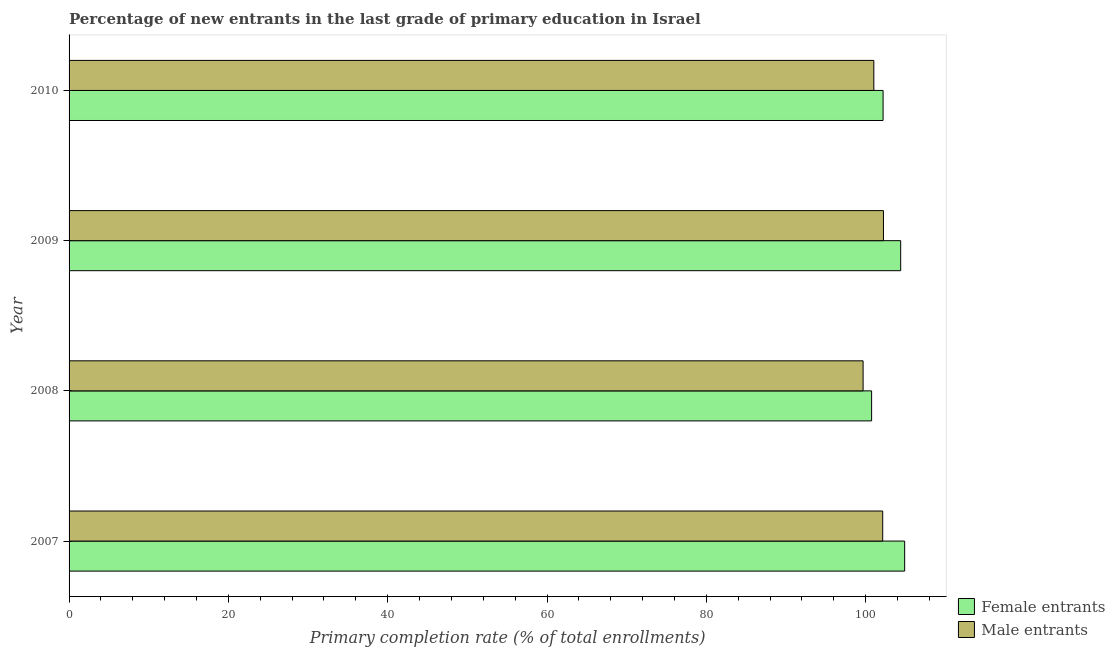Are the number of bars per tick equal to the number of legend labels?
Offer a terse response. Yes. How many bars are there on the 2nd tick from the top?
Ensure brevity in your answer.  2. How many bars are there on the 4th tick from the bottom?
Your answer should be compact. 2. What is the primary completion rate of male entrants in 2010?
Keep it short and to the point. 101.03. Across all years, what is the maximum primary completion rate of male entrants?
Make the answer very short. 102.24. Across all years, what is the minimum primary completion rate of female entrants?
Ensure brevity in your answer.  100.75. In which year was the primary completion rate of female entrants minimum?
Ensure brevity in your answer.  2008. What is the total primary completion rate of male entrants in the graph?
Make the answer very short. 405.1. What is the difference between the primary completion rate of female entrants in 2007 and that in 2010?
Offer a terse response. 2.71. What is the difference between the primary completion rate of female entrants in 2010 and the primary completion rate of male entrants in 2007?
Offer a very short reply. 0.05. What is the average primary completion rate of male entrants per year?
Provide a short and direct response. 101.28. In the year 2008, what is the difference between the primary completion rate of male entrants and primary completion rate of female entrants?
Give a very brief answer. -1.07. Is the primary completion rate of male entrants in 2007 less than that in 2010?
Make the answer very short. No. What is the difference between the highest and the second highest primary completion rate of female entrants?
Your answer should be very brief. 0.5. What is the difference between the highest and the lowest primary completion rate of female entrants?
Keep it short and to the point. 4.15. Is the sum of the primary completion rate of male entrants in 2008 and 2010 greater than the maximum primary completion rate of female entrants across all years?
Keep it short and to the point. Yes. What does the 1st bar from the top in 2007 represents?
Give a very brief answer. Male entrants. What does the 2nd bar from the bottom in 2008 represents?
Give a very brief answer. Male entrants. How many bars are there?
Make the answer very short. 8. How many years are there in the graph?
Ensure brevity in your answer.  4. What is the difference between two consecutive major ticks on the X-axis?
Provide a short and direct response. 20. Does the graph contain grids?
Your answer should be compact. No. How are the legend labels stacked?
Make the answer very short. Vertical. What is the title of the graph?
Your answer should be very brief. Percentage of new entrants in the last grade of primary education in Israel. Does "Public funds" appear as one of the legend labels in the graph?
Provide a short and direct response. No. What is the label or title of the X-axis?
Your answer should be very brief. Primary completion rate (% of total enrollments). What is the label or title of the Y-axis?
Give a very brief answer. Year. What is the Primary completion rate (% of total enrollments) in Female entrants in 2007?
Offer a very short reply. 104.9. What is the Primary completion rate (% of total enrollments) of Male entrants in 2007?
Keep it short and to the point. 102.15. What is the Primary completion rate (% of total enrollments) in Female entrants in 2008?
Provide a short and direct response. 100.75. What is the Primary completion rate (% of total enrollments) of Male entrants in 2008?
Your answer should be compact. 99.68. What is the Primary completion rate (% of total enrollments) in Female entrants in 2009?
Make the answer very short. 104.4. What is the Primary completion rate (% of total enrollments) of Male entrants in 2009?
Keep it short and to the point. 102.24. What is the Primary completion rate (% of total enrollments) in Female entrants in 2010?
Ensure brevity in your answer.  102.19. What is the Primary completion rate (% of total enrollments) in Male entrants in 2010?
Provide a succinct answer. 101.03. Across all years, what is the maximum Primary completion rate (% of total enrollments) in Female entrants?
Offer a terse response. 104.9. Across all years, what is the maximum Primary completion rate (% of total enrollments) in Male entrants?
Offer a terse response. 102.24. Across all years, what is the minimum Primary completion rate (% of total enrollments) in Female entrants?
Your response must be concise. 100.75. Across all years, what is the minimum Primary completion rate (% of total enrollments) in Male entrants?
Make the answer very short. 99.68. What is the total Primary completion rate (% of total enrollments) of Female entrants in the graph?
Offer a very short reply. 412.25. What is the total Primary completion rate (% of total enrollments) of Male entrants in the graph?
Offer a terse response. 405.1. What is the difference between the Primary completion rate (% of total enrollments) in Female entrants in 2007 and that in 2008?
Your response must be concise. 4.15. What is the difference between the Primary completion rate (% of total enrollments) of Male entrants in 2007 and that in 2008?
Provide a short and direct response. 2.46. What is the difference between the Primary completion rate (% of total enrollments) in Female entrants in 2007 and that in 2009?
Offer a very short reply. 0.5. What is the difference between the Primary completion rate (% of total enrollments) in Male entrants in 2007 and that in 2009?
Ensure brevity in your answer.  -0.09. What is the difference between the Primary completion rate (% of total enrollments) of Female entrants in 2007 and that in 2010?
Offer a very short reply. 2.71. What is the difference between the Primary completion rate (% of total enrollments) in Male entrants in 2007 and that in 2010?
Provide a succinct answer. 1.11. What is the difference between the Primary completion rate (% of total enrollments) of Female entrants in 2008 and that in 2009?
Ensure brevity in your answer.  -3.65. What is the difference between the Primary completion rate (% of total enrollments) in Male entrants in 2008 and that in 2009?
Your response must be concise. -2.56. What is the difference between the Primary completion rate (% of total enrollments) of Female entrants in 2008 and that in 2010?
Provide a succinct answer. -1.44. What is the difference between the Primary completion rate (% of total enrollments) of Male entrants in 2008 and that in 2010?
Your response must be concise. -1.35. What is the difference between the Primary completion rate (% of total enrollments) in Female entrants in 2009 and that in 2010?
Provide a succinct answer. 2.21. What is the difference between the Primary completion rate (% of total enrollments) in Male entrants in 2009 and that in 2010?
Provide a succinct answer. 1.21. What is the difference between the Primary completion rate (% of total enrollments) in Female entrants in 2007 and the Primary completion rate (% of total enrollments) in Male entrants in 2008?
Provide a short and direct response. 5.22. What is the difference between the Primary completion rate (% of total enrollments) in Female entrants in 2007 and the Primary completion rate (% of total enrollments) in Male entrants in 2009?
Give a very brief answer. 2.66. What is the difference between the Primary completion rate (% of total enrollments) in Female entrants in 2007 and the Primary completion rate (% of total enrollments) in Male entrants in 2010?
Offer a very short reply. 3.87. What is the difference between the Primary completion rate (% of total enrollments) in Female entrants in 2008 and the Primary completion rate (% of total enrollments) in Male entrants in 2009?
Offer a terse response. -1.49. What is the difference between the Primary completion rate (% of total enrollments) in Female entrants in 2008 and the Primary completion rate (% of total enrollments) in Male entrants in 2010?
Ensure brevity in your answer.  -0.28. What is the difference between the Primary completion rate (% of total enrollments) in Female entrants in 2009 and the Primary completion rate (% of total enrollments) in Male entrants in 2010?
Your response must be concise. 3.37. What is the average Primary completion rate (% of total enrollments) in Female entrants per year?
Your answer should be compact. 103.06. What is the average Primary completion rate (% of total enrollments) in Male entrants per year?
Give a very brief answer. 101.28. In the year 2007, what is the difference between the Primary completion rate (% of total enrollments) in Female entrants and Primary completion rate (% of total enrollments) in Male entrants?
Your response must be concise. 2.76. In the year 2008, what is the difference between the Primary completion rate (% of total enrollments) in Female entrants and Primary completion rate (% of total enrollments) in Male entrants?
Ensure brevity in your answer.  1.07. In the year 2009, what is the difference between the Primary completion rate (% of total enrollments) of Female entrants and Primary completion rate (% of total enrollments) of Male entrants?
Provide a short and direct response. 2.16. In the year 2010, what is the difference between the Primary completion rate (% of total enrollments) of Female entrants and Primary completion rate (% of total enrollments) of Male entrants?
Ensure brevity in your answer.  1.16. What is the ratio of the Primary completion rate (% of total enrollments) in Female entrants in 2007 to that in 2008?
Offer a very short reply. 1.04. What is the ratio of the Primary completion rate (% of total enrollments) in Male entrants in 2007 to that in 2008?
Make the answer very short. 1.02. What is the ratio of the Primary completion rate (% of total enrollments) in Female entrants in 2007 to that in 2009?
Your response must be concise. 1. What is the ratio of the Primary completion rate (% of total enrollments) of Male entrants in 2007 to that in 2009?
Give a very brief answer. 1. What is the ratio of the Primary completion rate (% of total enrollments) of Female entrants in 2007 to that in 2010?
Ensure brevity in your answer.  1.03. What is the ratio of the Primary completion rate (% of total enrollments) of Female entrants in 2008 to that in 2009?
Offer a very short reply. 0.96. What is the ratio of the Primary completion rate (% of total enrollments) in Male entrants in 2008 to that in 2009?
Provide a succinct answer. 0.97. What is the ratio of the Primary completion rate (% of total enrollments) of Female entrants in 2008 to that in 2010?
Keep it short and to the point. 0.99. What is the ratio of the Primary completion rate (% of total enrollments) of Male entrants in 2008 to that in 2010?
Ensure brevity in your answer.  0.99. What is the ratio of the Primary completion rate (% of total enrollments) of Female entrants in 2009 to that in 2010?
Offer a terse response. 1.02. What is the difference between the highest and the second highest Primary completion rate (% of total enrollments) in Female entrants?
Make the answer very short. 0.5. What is the difference between the highest and the second highest Primary completion rate (% of total enrollments) of Male entrants?
Your answer should be very brief. 0.09. What is the difference between the highest and the lowest Primary completion rate (% of total enrollments) of Female entrants?
Offer a terse response. 4.15. What is the difference between the highest and the lowest Primary completion rate (% of total enrollments) in Male entrants?
Your answer should be very brief. 2.56. 